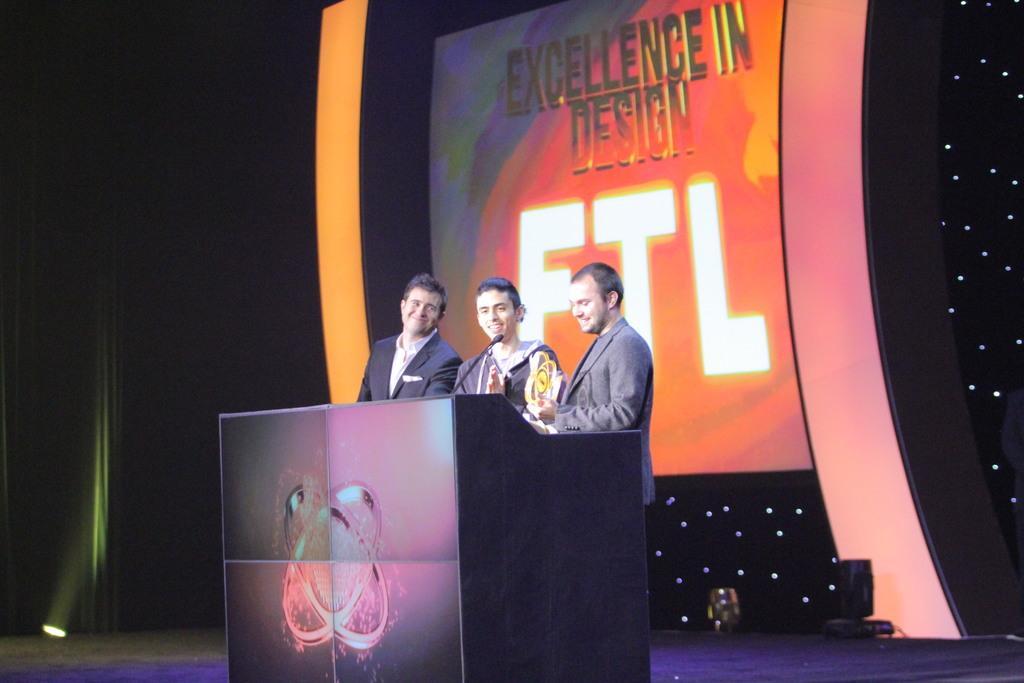In one or two sentences, can you explain what this image depicts? In this picture there is a stage. In the center of the picture there is a podium and there are three men standing. In the background there is a screen. On the left it is dark and there is a focus light. On the right there are small lights. 